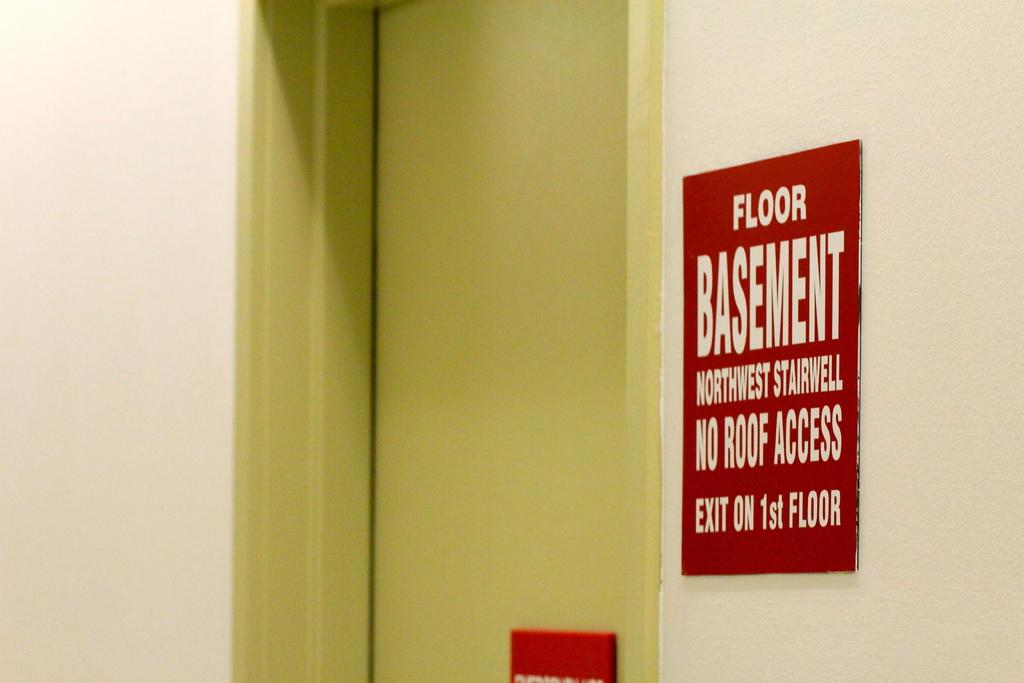<image>
Render a clear and concise summary of the photo. The sign indicating the basement's NW stairwell is red and white. 